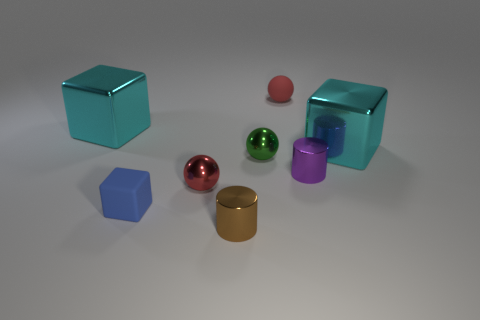Are there any rubber cubes that have the same color as the rubber sphere? no 